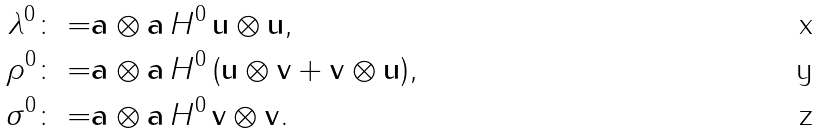Convert formula to latex. <formula><loc_0><loc_0><loc_500><loc_500>\lambda ^ { 0 } \colon = & { \mathbf a } \otimes { \mathbf a } \, H ^ { 0 } \, { \mathbf u } \otimes { \mathbf u } , \\ \rho ^ { 0 } \colon = & { \mathbf a } \otimes { \mathbf a } \, H ^ { 0 } \, ( { \mathbf u } \otimes { \mathbf v } + { \mathbf v } \otimes { \mathbf u } ) , \\ \sigma ^ { 0 } \colon = & { \mathbf a } \otimes { \mathbf a } \, H ^ { 0 } \, { \mathbf v } \otimes { \mathbf v } .</formula> 